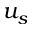<formula> <loc_0><loc_0><loc_500><loc_500>u _ { s }</formula> 